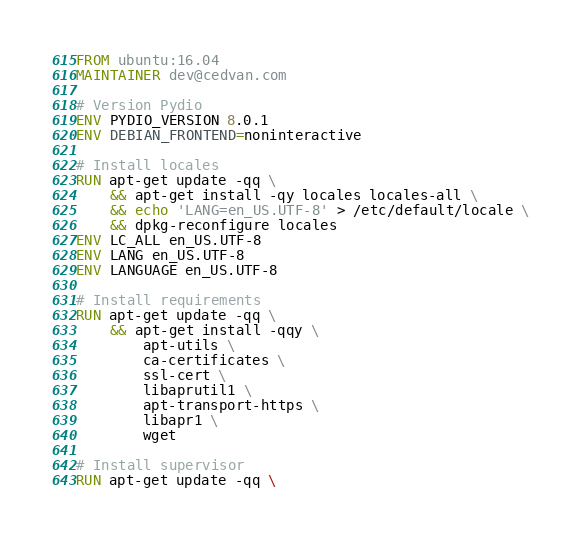Convert code to text. <code><loc_0><loc_0><loc_500><loc_500><_Dockerfile_>FROM ubuntu:16.04
MAINTAINER dev@cedvan.com

# Version Pydio
ENV PYDIO_VERSION 8.0.1
ENV DEBIAN_FRONTEND=noninteractive

# Install locales
RUN apt-get update -qq \
    && apt-get install -qy locales locales-all \
    && echo 'LANG=en_US.UTF-8' > /etc/default/locale \
    && dpkg-reconfigure locales
ENV LC_ALL en_US.UTF-8
ENV LANG en_US.UTF-8
ENV LANGUAGE en_US.UTF-8

# Install requirements
RUN apt-get update -qq \
    && apt-get install -qqy \
        apt-utils \
        ca-certificates \
        ssl-cert \
        libaprutil1 \
        apt-transport-https \
        libapr1 \
        wget

# Install supervisor
RUN apt-get update -qq \</code> 